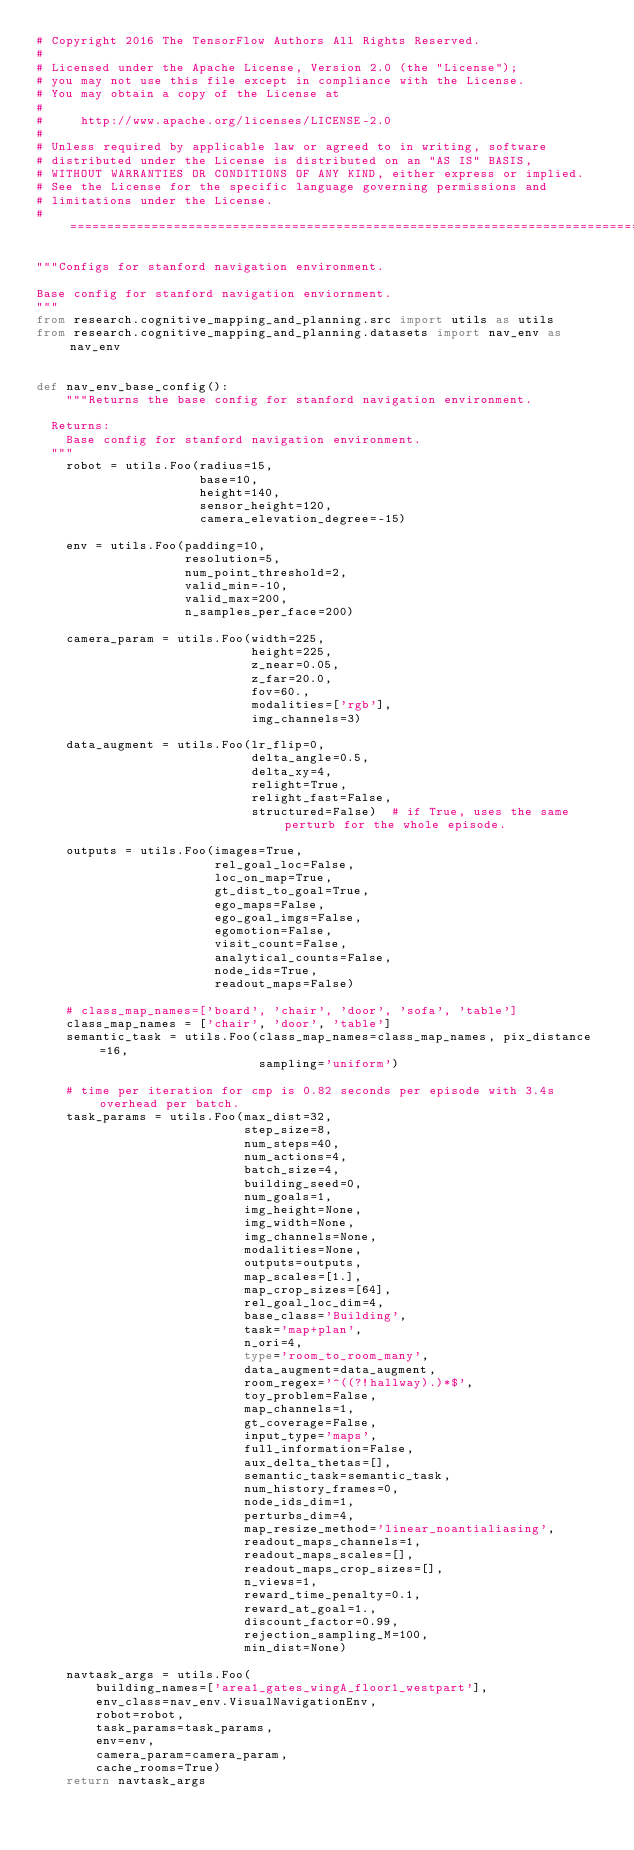Convert code to text. <code><loc_0><loc_0><loc_500><loc_500><_Python_># Copyright 2016 The TensorFlow Authors All Rights Reserved.
#
# Licensed under the Apache License, Version 2.0 (the "License");
# you may not use this file except in compliance with the License.
# You may obtain a copy of the License at
#
#     http://www.apache.org/licenses/LICENSE-2.0
#
# Unless required by applicable law or agreed to in writing, software
# distributed under the License is distributed on an "AS IS" BASIS,
# WITHOUT WARRANTIES OR CONDITIONS OF ANY KIND, either express or implied.
# See the License for the specific language governing permissions and
# limitations under the License.
# ==============================================================================

"""Configs for stanford navigation environment.

Base config for stanford navigation enviornment.
"""
from research.cognitive_mapping_and_planning.src import utils as utils
from research.cognitive_mapping_and_planning.datasets import nav_env as nav_env


def nav_env_base_config():
    """Returns the base config for stanford navigation environment.

  Returns:
    Base config for stanford navigation environment.
  """
    robot = utils.Foo(radius=15,
                      base=10,
                      height=140,
                      sensor_height=120,
                      camera_elevation_degree=-15)

    env = utils.Foo(padding=10,
                    resolution=5,
                    num_point_threshold=2,
                    valid_min=-10,
                    valid_max=200,
                    n_samples_per_face=200)

    camera_param = utils.Foo(width=225,
                             height=225,
                             z_near=0.05,
                             z_far=20.0,
                             fov=60.,
                             modalities=['rgb'],
                             img_channels=3)

    data_augment = utils.Foo(lr_flip=0,
                             delta_angle=0.5,
                             delta_xy=4,
                             relight=True,
                             relight_fast=False,
                             structured=False)  # if True, uses the same perturb for the whole episode.

    outputs = utils.Foo(images=True,
                        rel_goal_loc=False,
                        loc_on_map=True,
                        gt_dist_to_goal=True,
                        ego_maps=False,
                        ego_goal_imgs=False,
                        egomotion=False,
                        visit_count=False,
                        analytical_counts=False,
                        node_ids=True,
                        readout_maps=False)

    # class_map_names=['board', 'chair', 'door', 'sofa', 'table']
    class_map_names = ['chair', 'door', 'table']
    semantic_task = utils.Foo(class_map_names=class_map_names, pix_distance=16,
                              sampling='uniform')

    # time per iteration for cmp is 0.82 seconds per episode with 3.4s overhead per batch.
    task_params = utils.Foo(max_dist=32,
                            step_size=8,
                            num_steps=40,
                            num_actions=4,
                            batch_size=4,
                            building_seed=0,
                            num_goals=1,
                            img_height=None,
                            img_width=None,
                            img_channels=None,
                            modalities=None,
                            outputs=outputs,
                            map_scales=[1.],
                            map_crop_sizes=[64],
                            rel_goal_loc_dim=4,
                            base_class='Building',
                            task='map+plan',
                            n_ori=4,
                            type='room_to_room_many',
                            data_augment=data_augment,
                            room_regex='^((?!hallway).)*$',
                            toy_problem=False,
                            map_channels=1,
                            gt_coverage=False,
                            input_type='maps',
                            full_information=False,
                            aux_delta_thetas=[],
                            semantic_task=semantic_task,
                            num_history_frames=0,
                            node_ids_dim=1,
                            perturbs_dim=4,
                            map_resize_method='linear_noantialiasing',
                            readout_maps_channels=1,
                            readout_maps_scales=[],
                            readout_maps_crop_sizes=[],
                            n_views=1,
                            reward_time_penalty=0.1,
                            reward_at_goal=1.,
                            discount_factor=0.99,
                            rejection_sampling_M=100,
                            min_dist=None)

    navtask_args = utils.Foo(
        building_names=['area1_gates_wingA_floor1_westpart'],
        env_class=nav_env.VisualNavigationEnv,
        robot=robot,
        task_params=task_params,
        env=env,
        camera_param=camera_param,
        cache_rooms=True)
    return navtask_args
</code> 